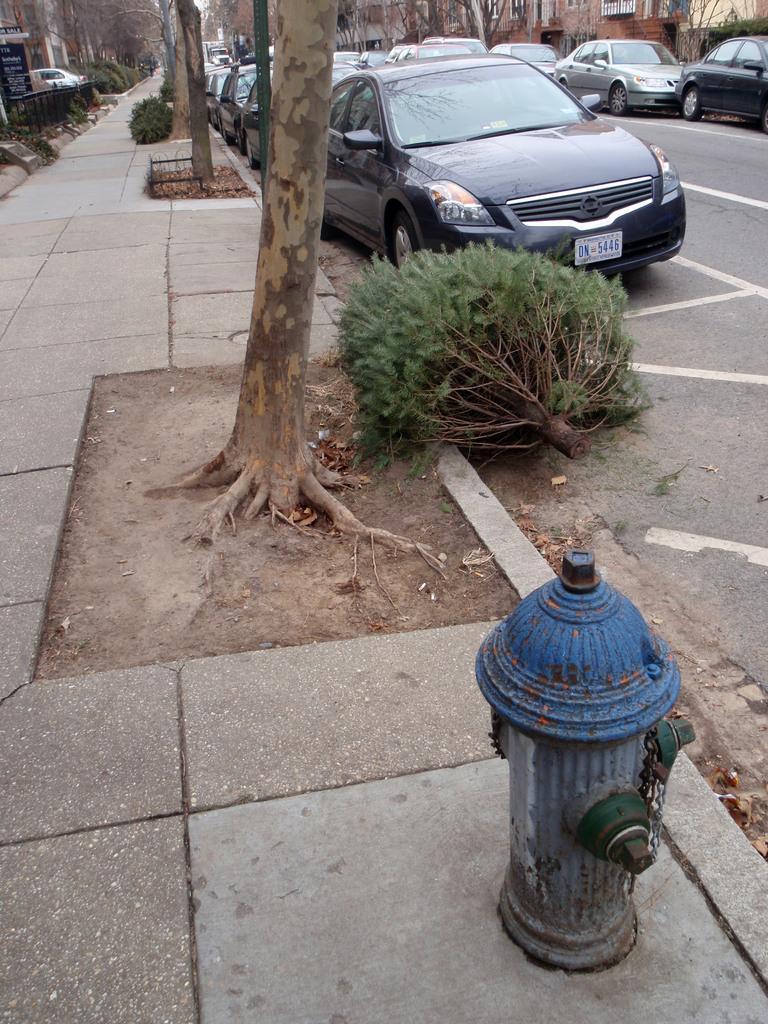Please provide a concise description of this image. In the foreground of the image there is a fire hydrant on the pavement. There are trees. To the right side of the image there are cars on the road. To the left side of the image there are buildings. 